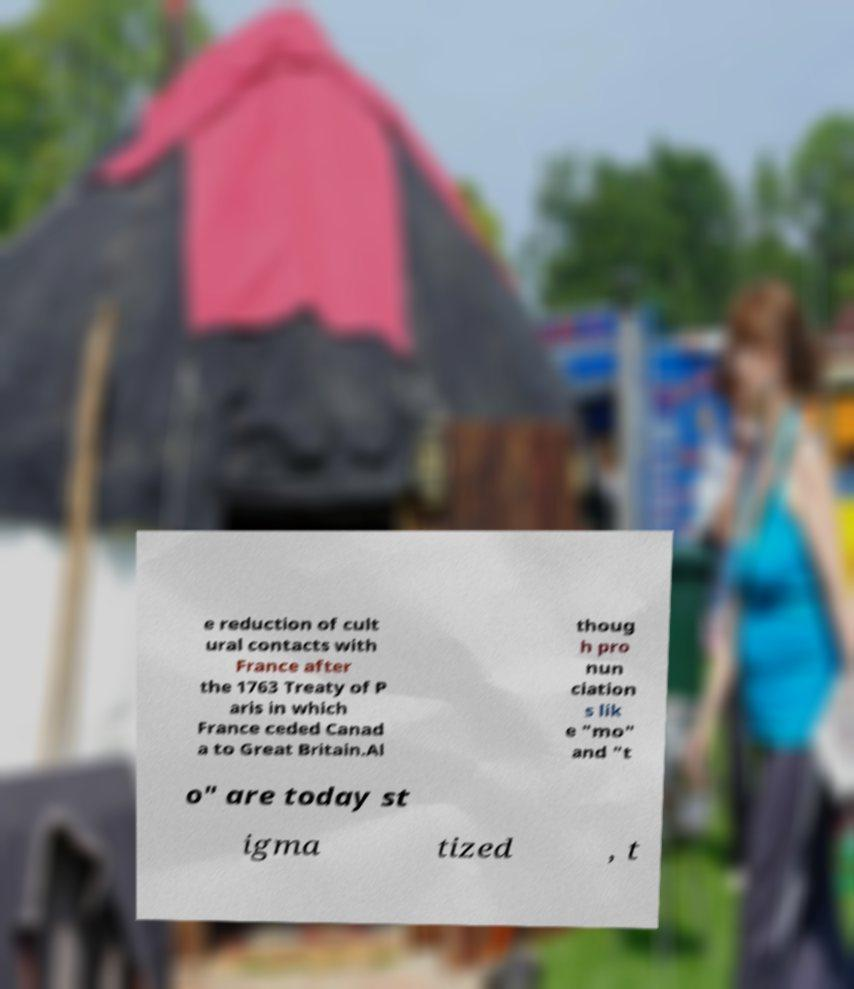I need the written content from this picture converted into text. Can you do that? e reduction of cult ural contacts with France after the 1763 Treaty of P aris in which France ceded Canad a to Great Britain.Al thoug h pro nun ciation s lik e "mo" and "t o" are today st igma tized , t 